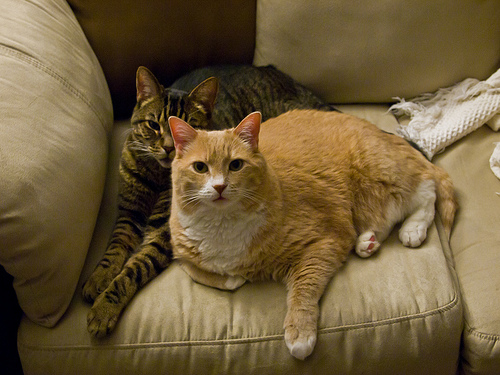<image>
Is the cat on the sofa? Yes. Looking at the image, I can see the cat is positioned on top of the sofa, with the sofa providing support. Is there a cat in the cushion? No. The cat is not contained within the cushion. These objects have a different spatial relationship. 